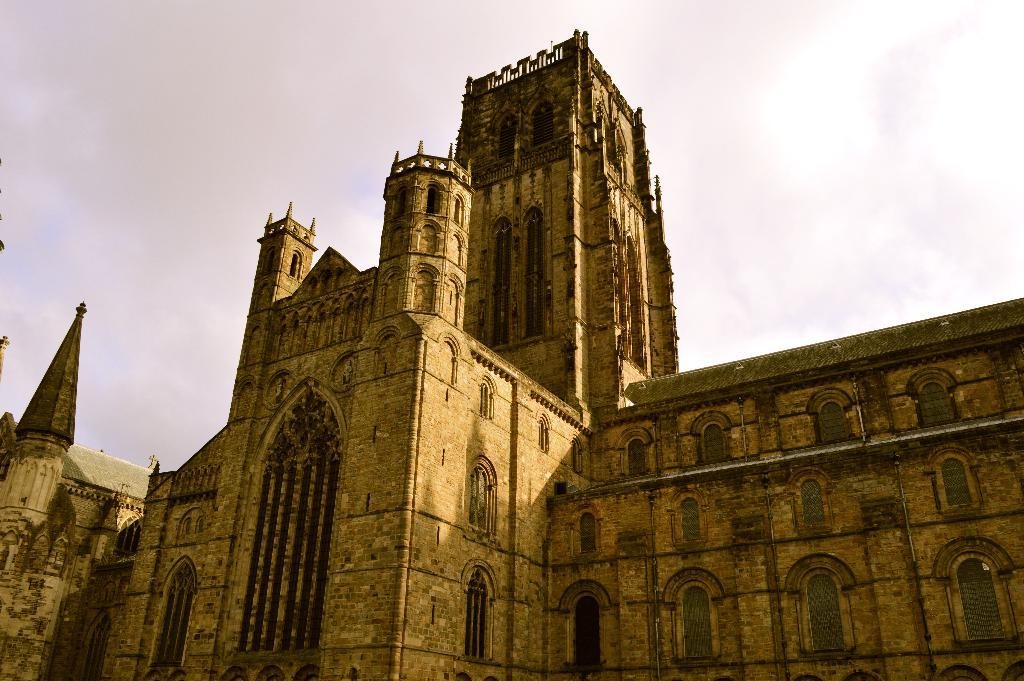What is the main structure visible in the image? There is a building in the image. What feature can be seen on the building? The building has windows. What is visible at the top of the image? The sky is visible at the top of the image. What can be observed in the sky? Clouds are present in the sky. Where is the cub located in the image? There is no cub present in the image. What type of breakfast is being served in the image? There is no breakfast depicted in the image. 